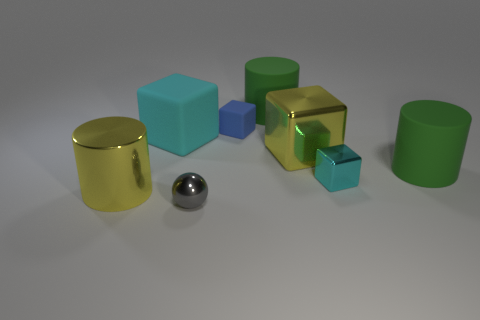What is the shape of the metal thing that is left of the tiny blue object and to the right of the large cyan block? sphere 